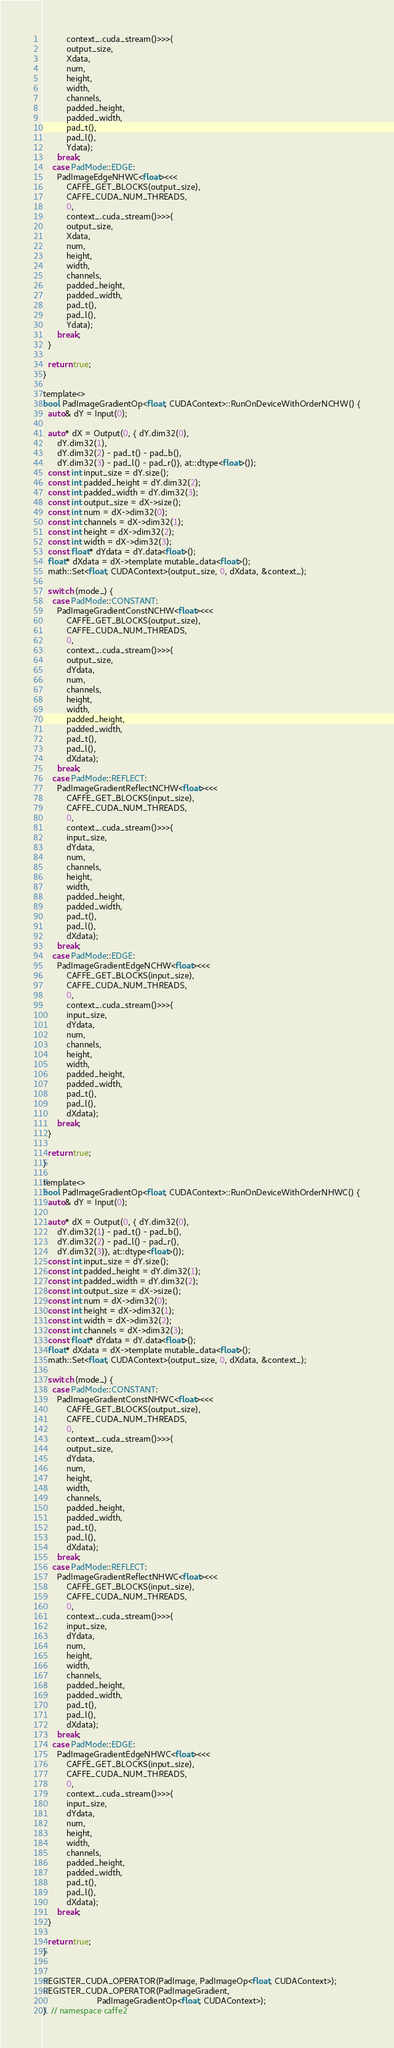<code> <loc_0><loc_0><loc_500><loc_500><_Cuda_>          context_.cuda_stream()>>>(
          output_size,
          Xdata,
          num,
          height,
          width,
          channels,
          padded_height,
          padded_width,
          pad_t(),
          pad_l(),
          Ydata);
      break;
    case PadMode::EDGE:
      PadImageEdgeNHWC<float><<<
          CAFFE_GET_BLOCKS(output_size),
          CAFFE_CUDA_NUM_THREADS,
          0,
          context_.cuda_stream()>>>(
          output_size,
          Xdata,
          num,
          height,
          width,
          channels,
          padded_height,
          padded_width,
          pad_t(),
          pad_l(),
          Ydata);
      break;
  }

  return true;
}

template<>
bool PadImageGradientOp<float, CUDAContext>::RunOnDeviceWithOrderNCHW() {
  auto& dY = Input(0);
  
  auto* dX = Output(0, { dY.dim32(0),
      dY.dim32(1),
      dY.dim32(2) - pad_t() - pad_b(),
      dY.dim32(3) - pad_l() - pad_r()}, at::dtype<float>());
  const int input_size = dY.size();
  const int padded_height = dY.dim32(2);
  const int padded_width = dY.dim32(3);
  const int output_size = dX->size();
  const int num = dX->dim32(0);
  const int channels = dX->dim32(1);
  const int height = dX->dim32(2);
  const int width = dX->dim32(3);
  const float* dYdata = dY.data<float>();
  float* dXdata = dX->template mutable_data<float>();
  math::Set<float, CUDAContext>(output_size, 0, dXdata, &context_);

  switch (mode_) {
    case PadMode::CONSTANT:
      PadImageGradientConstNCHW<float><<<
          CAFFE_GET_BLOCKS(output_size),
          CAFFE_CUDA_NUM_THREADS,
          0,
          context_.cuda_stream()>>>(
          output_size,
          dYdata,
          num,
          channels,
          height,
          width,
          padded_height,
          padded_width,
          pad_t(),
          pad_l(),
          dXdata);
      break;
    case PadMode::REFLECT:
      PadImageGradientReflectNCHW<float><<<
          CAFFE_GET_BLOCKS(input_size),
          CAFFE_CUDA_NUM_THREADS,
          0,
          context_.cuda_stream()>>>(
          input_size,
          dYdata,
          num,
          channels,
          height,
          width,
          padded_height,
          padded_width,
          pad_t(),
          pad_l(),
          dXdata);
      break;
    case PadMode::EDGE:
      PadImageGradientEdgeNCHW<float><<<
          CAFFE_GET_BLOCKS(input_size),
          CAFFE_CUDA_NUM_THREADS,
          0,
          context_.cuda_stream()>>>(
          input_size,
          dYdata,
          num,
          channels,
          height,
          width,
          padded_height,
          padded_width,
          pad_t(),
          pad_l(),
          dXdata);
      break;
  }

  return true;
}

template<>
bool PadImageGradientOp<float, CUDAContext>::RunOnDeviceWithOrderNHWC() {
  auto& dY = Input(0);
  
  auto* dX = Output(0, { dY.dim32(0),
      dY.dim32(1) - pad_t() - pad_b(),
      dY.dim32(2) - pad_l() - pad_r(),
      dY.dim32(3)}, at::dtype<float>());
  const int input_size = dY.size();
  const int padded_height = dY.dim32(1);
  const int padded_width = dY.dim32(2);
  const int output_size = dX->size();
  const int num = dX->dim32(0);
  const int height = dX->dim32(1);
  const int width = dX->dim32(2);
  const int channels = dX->dim32(3);
  const float* dYdata = dY.data<float>();
  float* dXdata = dX->template mutable_data<float>();
  math::Set<float, CUDAContext>(output_size, 0, dXdata, &context_);

  switch (mode_) {
    case PadMode::CONSTANT:
      PadImageGradientConstNHWC<float><<<
          CAFFE_GET_BLOCKS(output_size),
          CAFFE_CUDA_NUM_THREADS,
          0,
          context_.cuda_stream()>>>(
          output_size,
          dYdata,
          num,
          height,
          width,
          channels,
          padded_height,
          padded_width,
          pad_t(),
          pad_l(),
          dXdata);
      break;
    case PadMode::REFLECT:
      PadImageGradientReflectNHWC<float><<<
          CAFFE_GET_BLOCKS(input_size),
          CAFFE_CUDA_NUM_THREADS,
          0,
          context_.cuda_stream()>>>(
          input_size,
          dYdata,
          num,
          height,
          width,
          channels,
          padded_height,
          padded_width,
          pad_t(),
          pad_l(),
          dXdata);
      break;
    case PadMode::EDGE:
      PadImageGradientEdgeNHWC<float><<<
          CAFFE_GET_BLOCKS(input_size),
          CAFFE_CUDA_NUM_THREADS,
          0,
          context_.cuda_stream()>>>(
          input_size,
          dYdata,
          num,
          height,
          width,
          channels,
          padded_height,
          padded_width,
          pad_t(),
          pad_l(),
          dXdata);
      break;
  }

  return true;
}


REGISTER_CUDA_OPERATOR(PadImage, PadImageOp<float, CUDAContext>);
REGISTER_CUDA_OPERATOR(PadImageGradient,
                       PadImageGradientOp<float, CUDAContext>);
}  // namespace caffe2
</code> 